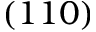<formula> <loc_0><loc_0><loc_500><loc_500>\left ( 1 1 0 \right )</formula> 